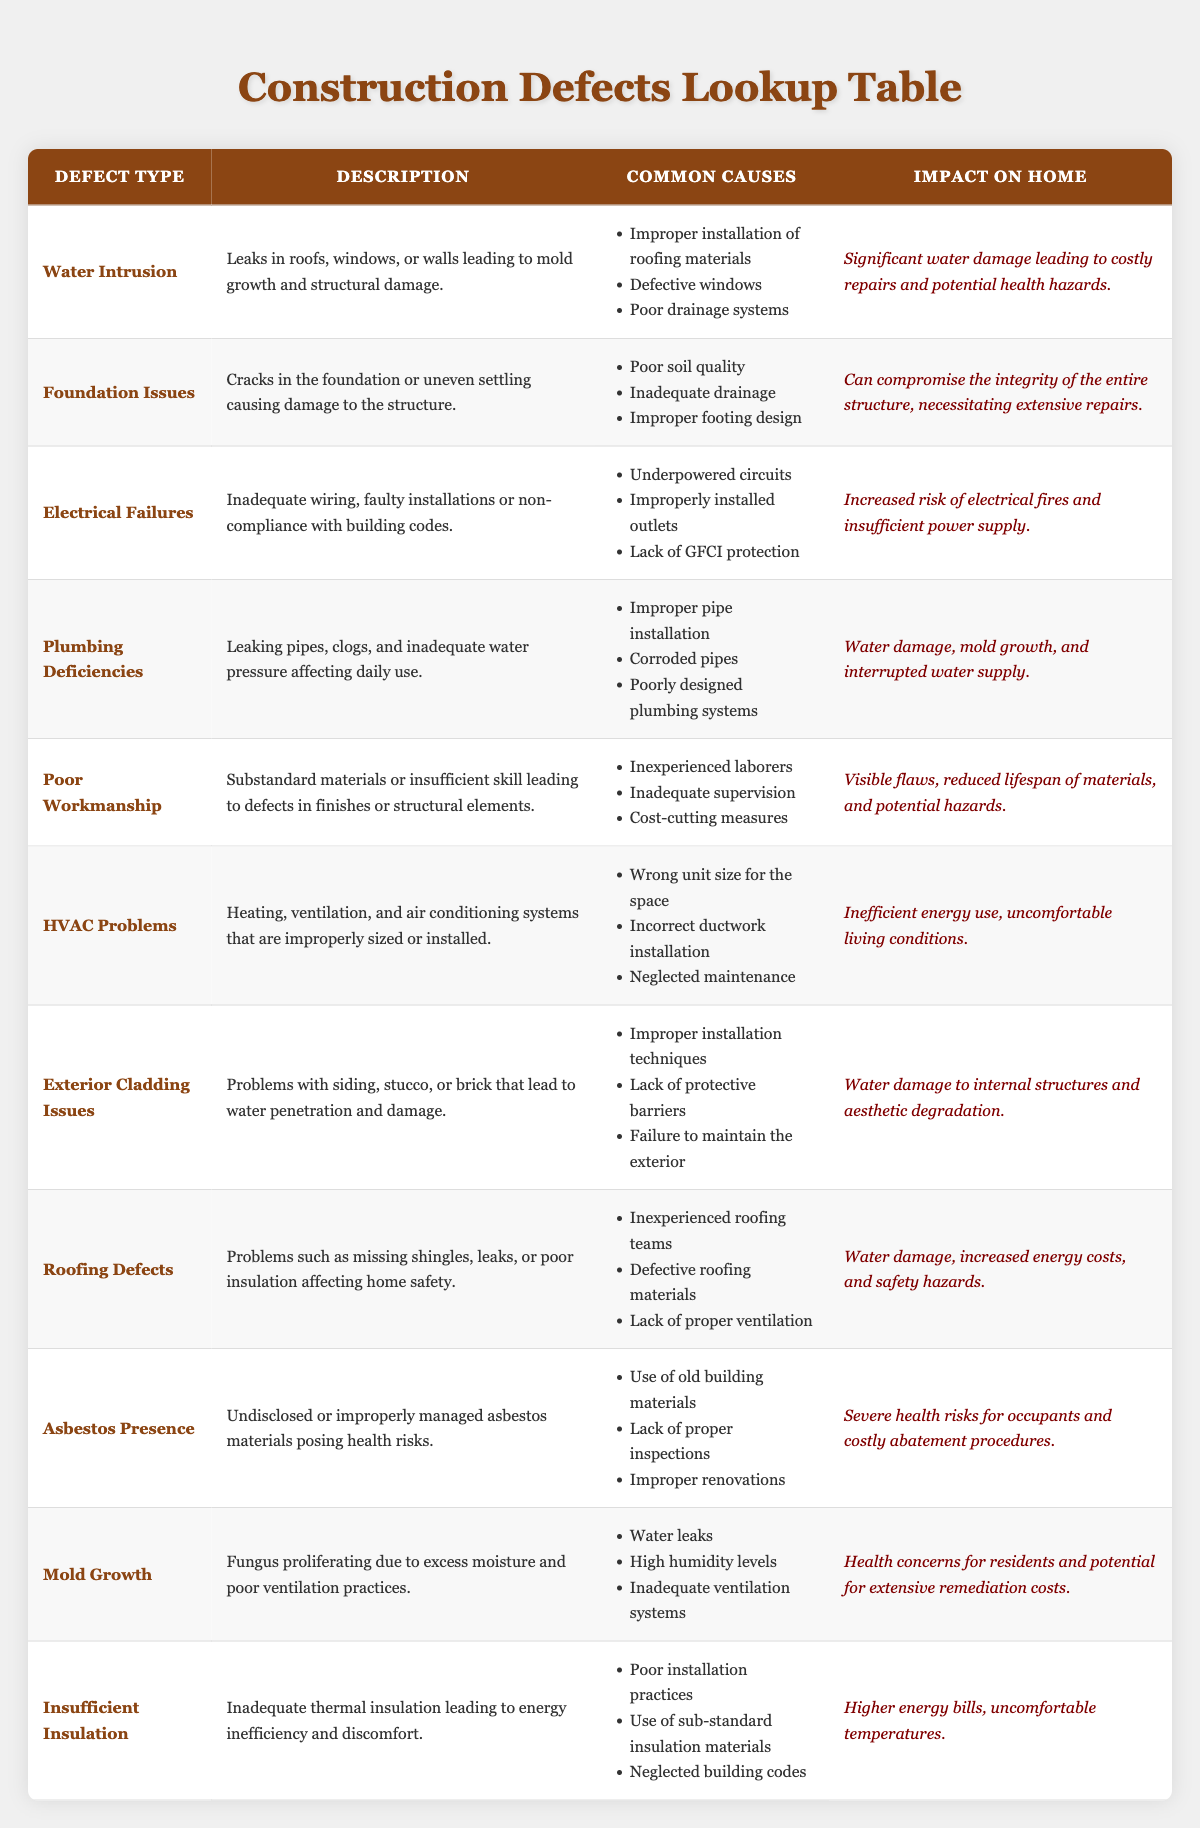What is the defect type associated with water damage leading to costly repairs? The table lists "Water Intrusion" as a defect type that leads to significant water damage and costly repairs. This can be found directly in the first row of the table under "Defect Type."
Answer: Water Intrusion How many defect types are associated with inadequate installation? The defect types that mention inadequate or improper installation in their descriptions are: Water Intrusion, Plumbing Deficiencies, HVAC Problems, and Roofing Defects. Counting these gives a total of four defect types. Each of these entries includes some reference to improper installation practices.
Answer: 4 Is mold growth caused by water leaks according to the data? Yes, the table describes mold growth as being caused by "water leaks." This is mentioned in the "Common Causes" column for the Mold Growth row, confirming that this statement is true.
Answer: Yes Which defect type could significantly compromise the integrity of a home? The table specifies "Foundation Issues" as a defect type that can compromise the integrity of the entire structure, constituting a major concern for homeowners. This is clearly stated in the Impact on Home section for Foundation Issues.
Answer: Foundation Issues What are the common causes listed for electrical failures? The common causes of electrical failures listed in the table are: underpowered circuits, improperly installed outlets, and lack of GFCI protection. These are directly observable in the "Common Causes" column for the Electrical Failures entry.
Answer: Underpowered circuits, improperly installed outlets, lack of GFCI protection Which defect types mention moisture-related problems in their descriptions? The defect types that relate explicitly to moisture are: Water Intrusion, Mold Growth, and Plumbing Deficiencies. Water Intrusion and Plumbing Deficiencies both highlight issues with water, while Mold Growth is defined by excess moisture as a cause. This identifies three total defect types with moisture-related issues.
Answer: 3 Are exterior cladding issues likely to lead to water damage according to the table? Yes, the table indicates that exterior cladding issues can lead to water penetration and damage, thus posing a significant risk for water damage. This is stated in the Description column for Exterior Cladding Issues.
Answer: Yes What is the impact of insufficient insulation on a home? The table states that insufficient insulation can lead to higher energy bills and uncomfortable temperatures, highlighting its economic and comfort-related implications for homeowners. This is described under the Impact on Home section for Insufficient Insulation.
Answer: Higher energy bills, uncomfortable temperatures Which defect types are associated with health risks? The defect types that pose health risks mentioned in the table are Asbestos Presence and Mold Growth. Asbestos Presence involves undisclosed or improperly managed materials posing health risks, while Mold Growth cites health concerns for residents due to excess moisture. This gives us two specific defect types indicating health risks.
Answer: 2 